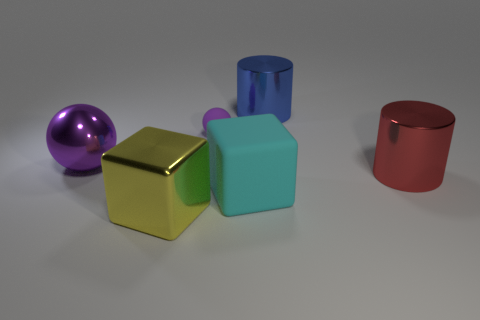What number of objects are either spheres left of the big yellow block or blue matte things?
Make the answer very short. 1. What is the color of the large metallic ball?
Ensure brevity in your answer.  Purple. There is a purple sphere in front of the tiny purple ball; what is it made of?
Provide a short and direct response. Metal. There is a large purple shiny thing; is its shape the same as the large metal object that is in front of the big red shiny object?
Keep it short and to the point. No. Is the number of small purple matte spheres greater than the number of green balls?
Ensure brevity in your answer.  Yes. Is there any other thing that has the same color as the small object?
Provide a short and direct response. Yes. The blue object that is made of the same material as the big purple sphere is what shape?
Offer a very short reply. Cylinder. The purple ball that is in front of the matte thing to the left of the large cyan block is made of what material?
Offer a very short reply. Metal. There is a rubber object that is to the left of the big cyan thing; is its shape the same as the red shiny object?
Offer a very short reply. No. Are there more yellow metallic things in front of the big purple ball than small purple metal spheres?
Provide a succinct answer. Yes. 